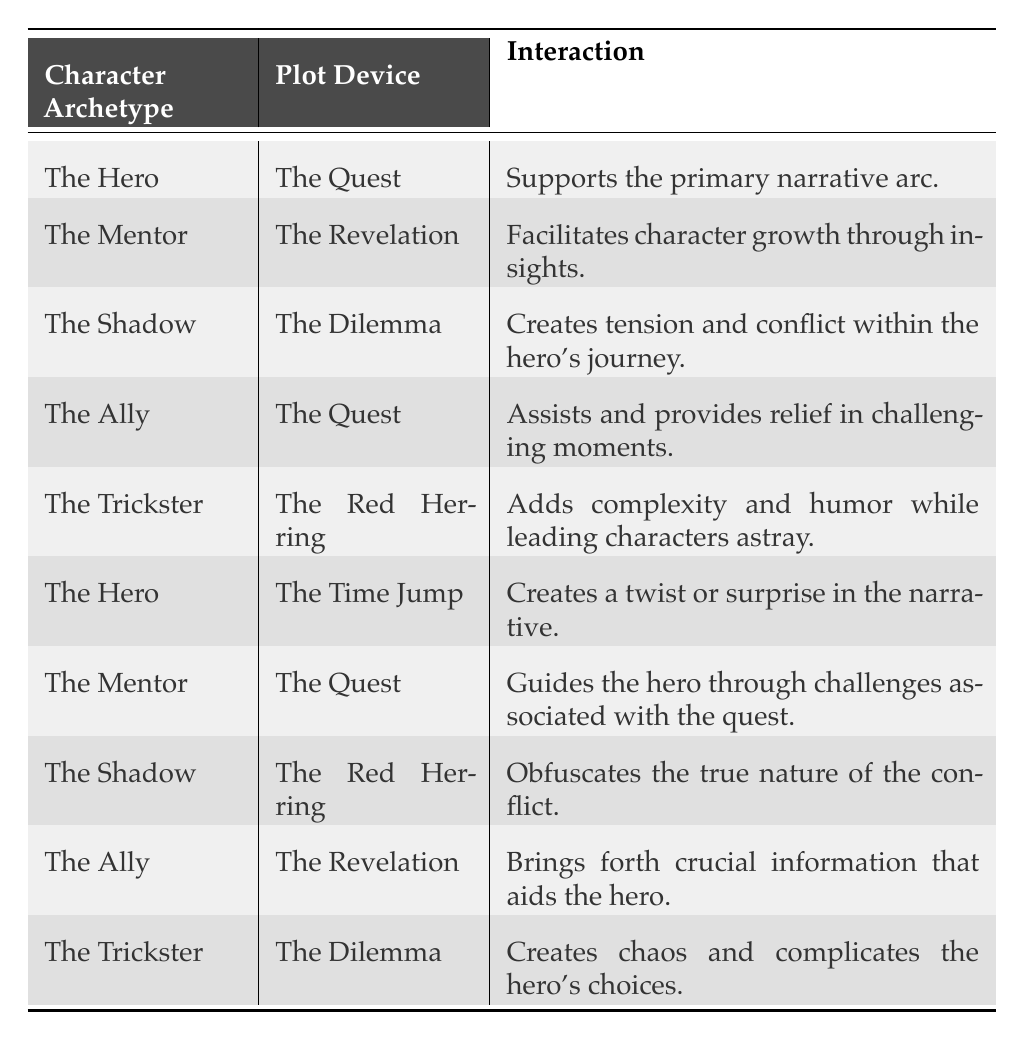What is the interaction associated with "The Hero" and "The Quest"? From the table, we can locate the row where "Character Archetype" is "The Hero" and "Plot Device" is "The Quest." The corresponding interaction listed is "Supports the primary narrative arc."
Answer: Supports the primary narrative arc Which character archetype is linked to "The Revelation"? By examining the table, we find the row where "Plot Device" is "The Revelation." The character archetype associated with it is "The Mentor."
Answer: The Mentor Is "The Trickster" associated with "The Dilemma"? We can check the row for "The Trickster" and see what plot device it is associated with. The table shows that "The Trickster" is linked to "The Dilemma," so the answer is true.
Answer: Yes How many times does "The Quest" appear as a plot device in relation to character archetypes? Looking through the table, we note each instance of "The Quest." It appears in the interactions for both "The Hero" and "The Ally," which makes a total of two occurrences.
Answer: 2 Which character archetype has an interaction that creates tension within the hero's journey? By scanning the table, we identify "The Shadow" associated with "The Dilemma," where it states that it "Creates tension and conflict within the hero's journey."
Answer: The Shadow What are the interactions associated with "The Mentor"? We look at all instances where "The Mentor" appears, which is connected to "The Revelation" (facilitating growth) and also to "The Quest" (guiding the hero). This yields two interactions.
Answer: Two interactions Does "The Red Herring" contribute to the protagonist's journey positively? In the table, we see "The Trickster" links to "The Red Herring," stating it "Adds complexity and humor while leading characters astray." This implies a negative contribution.
Answer: No What is the difference in interactions between "The Hero" when paired with "The Quest" and "The Time Jump"? We analyze both interactions for "The Hero": with "The Quest," it says it "Supports the primary narrative arc," while with "The Time Jump," it mentions it "Creates a twist or surprise in the narrative." The difference is the type of influence each has on the plot development: supportive vs. surprising.
Answer: Supportive vs. surprising 